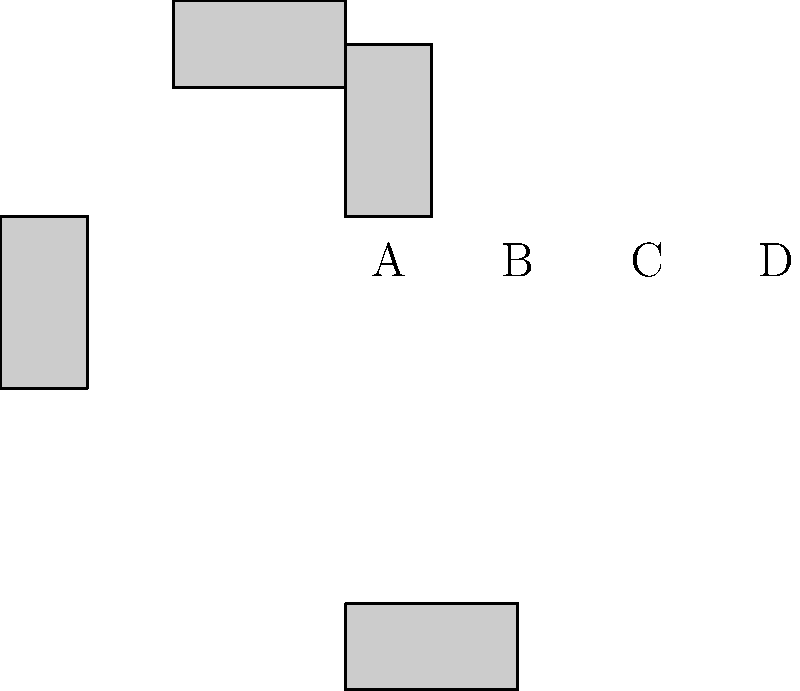In ancient Egyptian hieroglyphic writing, the orientation of symbols was crucial for correct interpretation. Based on your knowledge of Egyptian history, which of the hieroglyphs shown above (A, B, C, or D) is oriented correctly for reading from left to right? To determine the correct orientation of Egyptian hieroglyphs, we need to consider the following steps:

1. Ancient Egyptian hieroglyphs were typically read from right to left, top to bottom. However, they could also be read from left to right, depending on which direction the symbols were facing.

2. When reading from left to right, the hieroglyphs should face towards the beginning of the text (i.e., to the left).

3. Examining the given hieroglyphs:
   A: Oriented upright, facing right
   B: Rotated 90 degrees clockwise, facing down
   C: Rotated 180 degrees, facing left
   D: Rotated 270 degrees clockwise (90 degrees counterclockwise), facing up

4. Since we're asked about reading from left to right, we need to find the hieroglyph facing left.

5. Only hieroglyph C is facing left, which is the correct orientation for reading from left to right.

Therefore, the correctly oriented hieroglyph for reading from left to right is C.
Answer: C 